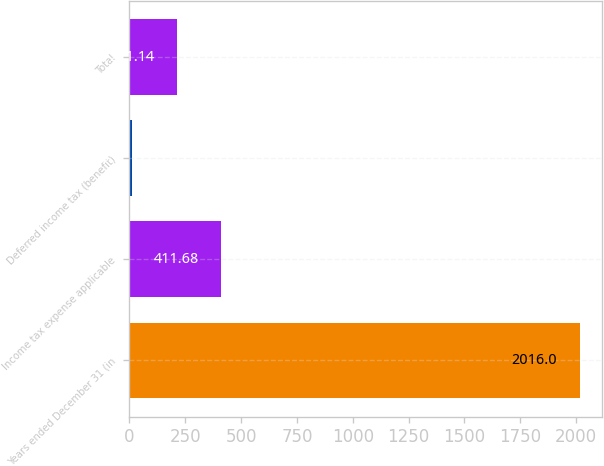<chart> <loc_0><loc_0><loc_500><loc_500><bar_chart><fcel>Years ended December 31 (in<fcel>Income tax expense applicable<fcel>Deferred income tax (benefit)<fcel>Total<nl><fcel>2016<fcel>411.68<fcel>10.6<fcel>211.14<nl></chart> 